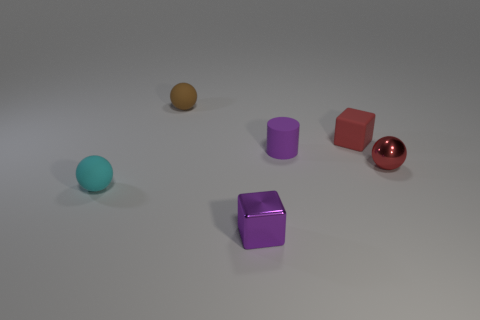What is the shape of the tiny rubber object that is both in front of the tiny red cube and to the right of the cyan ball? The tiny rubber object positioned in front of the small red cube and to the right of the cyan ball is shaped like a cylinder. This item's cylindrical form is characterized by its circular base and elongated height, similar to that of a classic rubber eraser, but with more rounded edges and a glossy surface often found in rubber materials. 